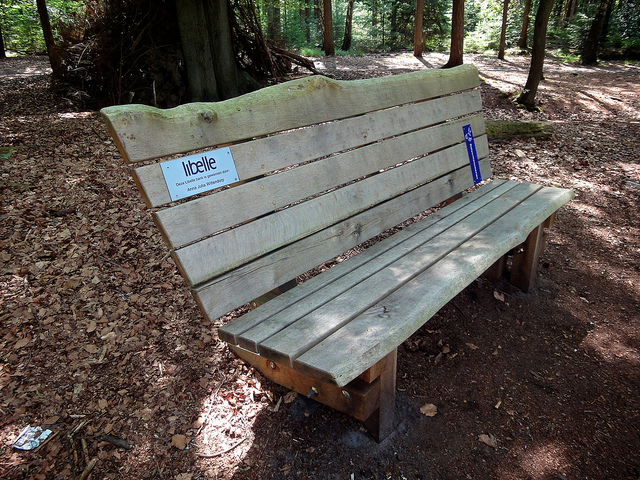<image>What color is the sign on the right of the bench? I am not sure what color is the sign on the right of the bench. It can be seen blue or white. What color is the sign on the right of the bench? It can be seen 'blue' on the right side of the bench. 